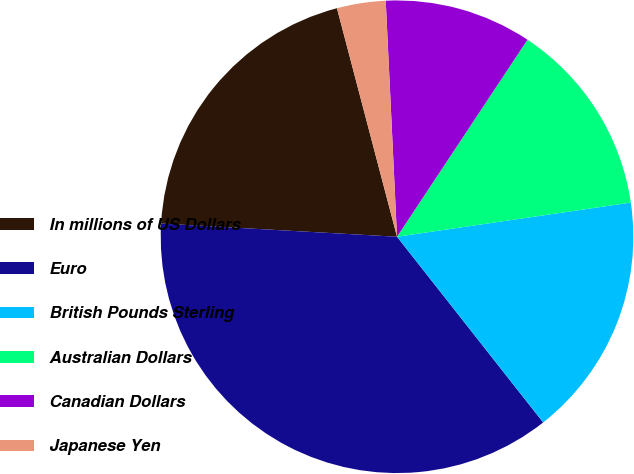<chart> <loc_0><loc_0><loc_500><loc_500><pie_chart><fcel>In millions of US Dollars<fcel>Euro<fcel>British Pounds Sterling<fcel>Australian Dollars<fcel>Canadian Dollars<fcel>Japanese Yen<nl><fcel>20.02%<fcel>36.5%<fcel>16.7%<fcel>13.38%<fcel>10.07%<fcel>3.33%<nl></chart> 